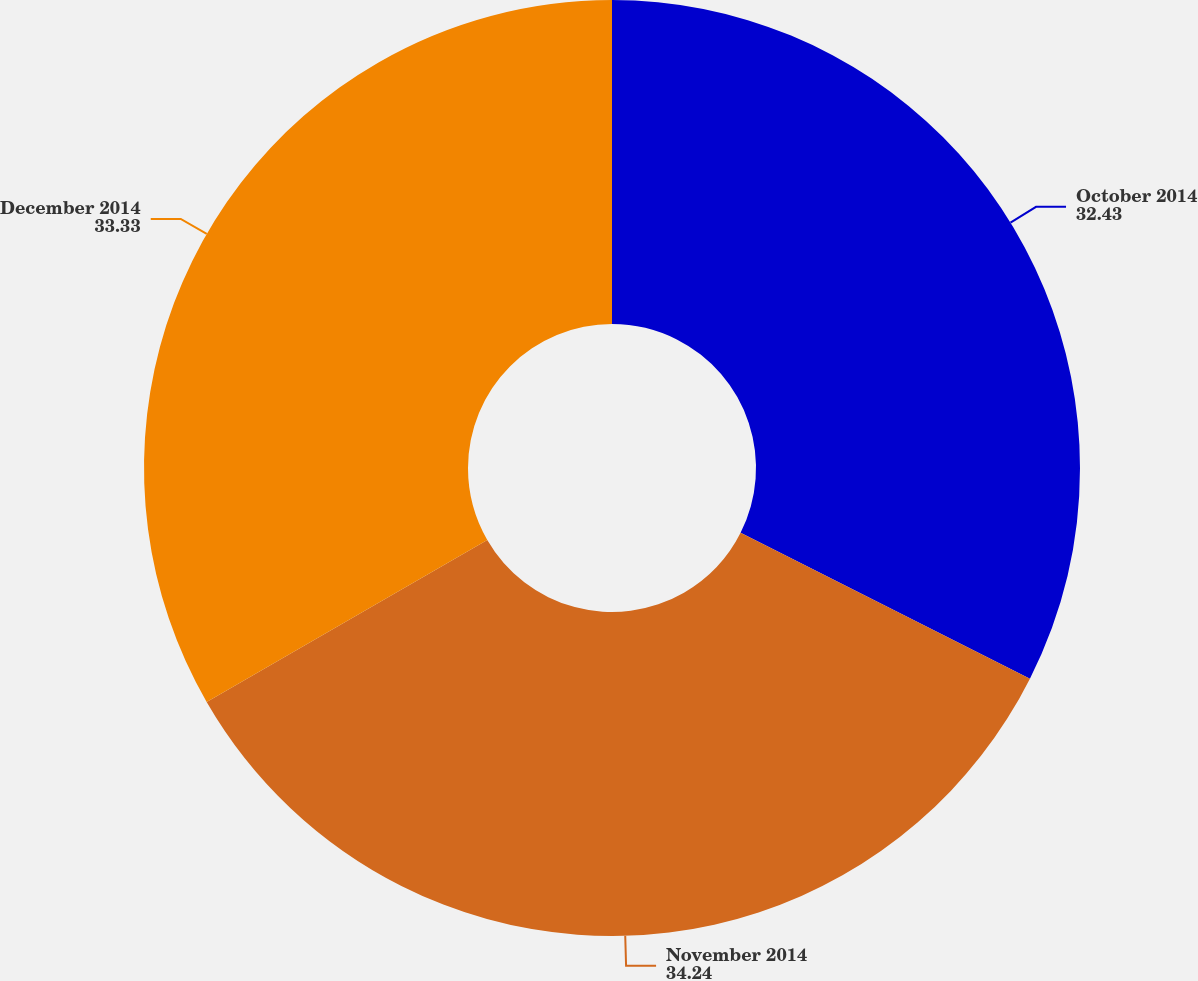<chart> <loc_0><loc_0><loc_500><loc_500><pie_chart><fcel>October 2014<fcel>November 2014<fcel>December 2014<nl><fcel>32.43%<fcel>34.24%<fcel>33.33%<nl></chart> 